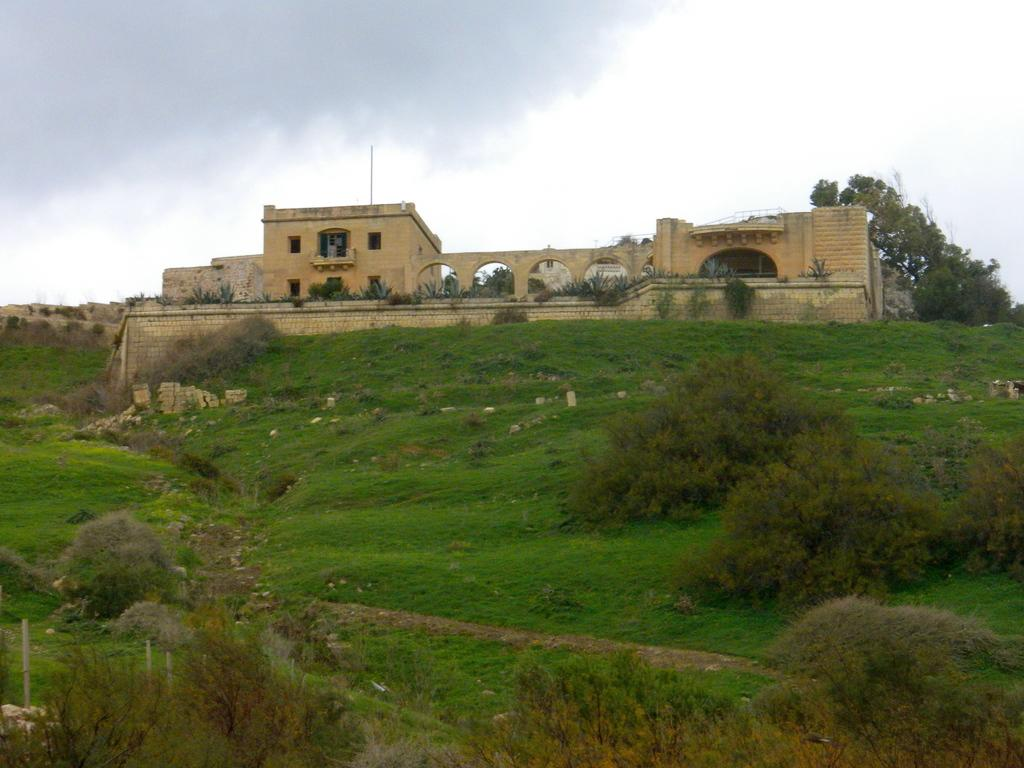What type of vegetation can be seen in the image? There is grass, plants, and trees in the image. What structures are present in the image? There are buildings in the image. What part of the natural environment is visible in the image? The sky is visible in the background of the image. What type of ball can be seen rolling on the grass in the image? There is no ball present in the image; it only features grass, plants, trees, buildings, and the sky. 